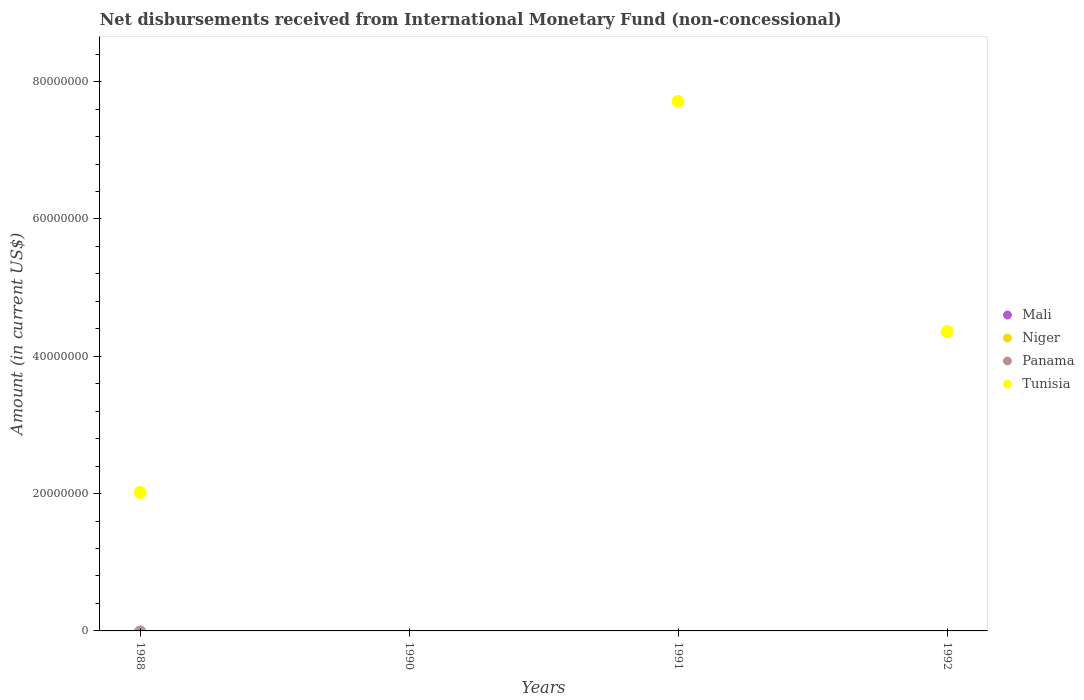How many different coloured dotlines are there?
Ensure brevity in your answer.  1. Is the number of dotlines equal to the number of legend labels?
Your answer should be very brief. No. What is the amount of disbursements received from International Monetary Fund in Panama in 1988?
Offer a very short reply. 0. Across all years, what is the maximum amount of disbursements received from International Monetary Fund in Tunisia?
Your response must be concise. 7.71e+07. Across all years, what is the minimum amount of disbursements received from International Monetary Fund in Mali?
Offer a very short reply. 0. In which year was the amount of disbursements received from International Monetary Fund in Tunisia maximum?
Offer a very short reply. 1991. What is the total amount of disbursements received from International Monetary Fund in Tunisia in the graph?
Provide a short and direct response. 1.41e+08. What is the difference between the amount of disbursements received from International Monetary Fund in Tunisia in 1988 and that in 1992?
Give a very brief answer. -2.34e+07. What is the difference between the amount of disbursements received from International Monetary Fund in Mali in 1992 and the amount of disbursements received from International Monetary Fund in Niger in 1990?
Ensure brevity in your answer.  0. In how many years, is the amount of disbursements received from International Monetary Fund in Tunisia greater than 52000000 US$?
Offer a very short reply. 1. What is the ratio of the amount of disbursements received from International Monetary Fund in Tunisia in 1988 to that in 1991?
Your response must be concise. 0.26. Is the amount of disbursements received from International Monetary Fund in Tunisia in 1988 less than that in 1991?
Keep it short and to the point. Yes. What is the difference between the highest and the second highest amount of disbursements received from International Monetary Fund in Tunisia?
Make the answer very short. 3.35e+07. What is the difference between the highest and the lowest amount of disbursements received from International Monetary Fund in Tunisia?
Ensure brevity in your answer.  7.71e+07. Is it the case that in every year, the sum of the amount of disbursements received from International Monetary Fund in Panama and amount of disbursements received from International Monetary Fund in Tunisia  is greater than the amount of disbursements received from International Monetary Fund in Mali?
Your response must be concise. No. Is the amount of disbursements received from International Monetary Fund in Panama strictly less than the amount of disbursements received from International Monetary Fund in Mali over the years?
Offer a terse response. No. Are the values on the major ticks of Y-axis written in scientific E-notation?
Give a very brief answer. No. Does the graph contain any zero values?
Your answer should be very brief. Yes. How are the legend labels stacked?
Keep it short and to the point. Vertical. What is the title of the graph?
Provide a short and direct response. Net disbursements received from International Monetary Fund (non-concessional). Does "Arab World" appear as one of the legend labels in the graph?
Your response must be concise. No. What is the label or title of the Y-axis?
Your response must be concise. Amount (in current US$). What is the Amount (in current US$) in Tunisia in 1988?
Provide a succinct answer. 2.02e+07. What is the Amount (in current US$) in Mali in 1990?
Offer a terse response. 0. What is the Amount (in current US$) in Niger in 1990?
Your answer should be compact. 0. What is the Amount (in current US$) of Tunisia in 1990?
Keep it short and to the point. 0. What is the Amount (in current US$) in Mali in 1991?
Offer a terse response. 0. What is the Amount (in current US$) in Niger in 1991?
Provide a succinct answer. 0. What is the Amount (in current US$) in Tunisia in 1991?
Give a very brief answer. 7.71e+07. What is the Amount (in current US$) in Niger in 1992?
Make the answer very short. 0. What is the Amount (in current US$) in Tunisia in 1992?
Your response must be concise. 4.36e+07. Across all years, what is the maximum Amount (in current US$) in Tunisia?
Keep it short and to the point. 7.71e+07. What is the total Amount (in current US$) in Mali in the graph?
Offer a terse response. 0. What is the total Amount (in current US$) of Panama in the graph?
Make the answer very short. 0. What is the total Amount (in current US$) in Tunisia in the graph?
Ensure brevity in your answer.  1.41e+08. What is the difference between the Amount (in current US$) in Tunisia in 1988 and that in 1991?
Provide a succinct answer. -5.70e+07. What is the difference between the Amount (in current US$) in Tunisia in 1988 and that in 1992?
Provide a succinct answer. -2.34e+07. What is the difference between the Amount (in current US$) of Tunisia in 1991 and that in 1992?
Your response must be concise. 3.35e+07. What is the average Amount (in current US$) of Panama per year?
Your response must be concise. 0. What is the average Amount (in current US$) of Tunisia per year?
Make the answer very short. 3.52e+07. What is the ratio of the Amount (in current US$) of Tunisia in 1988 to that in 1991?
Ensure brevity in your answer.  0.26. What is the ratio of the Amount (in current US$) of Tunisia in 1988 to that in 1992?
Ensure brevity in your answer.  0.46. What is the ratio of the Amount (in current US$) of Tunisia in 1991 to that in 1992?
Provide a short and direct response. 1.77. What is the difference between the highest and the second highest Amount (in current US$) of Tunisia?
Ensure brevity in your answer.  3.35e+07. What is the difference between the highest and the lowest Amount (in current US$) in Tunisia?
Your response must be concise. 7.71e+07. 